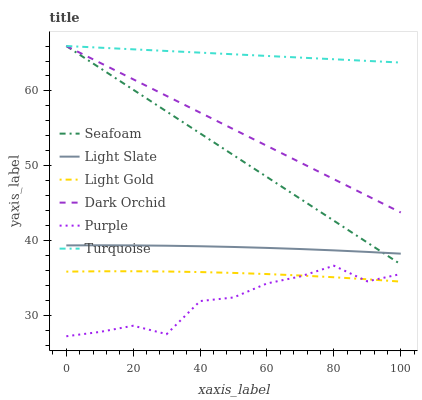Does Purple have the minimum area under the curve?
Answer yes or no. Yes. Does Turquoise have the maximum area under the curve?
Answer yes or no. Yes. Does Light Slate have the minimum area under the curve?
Answer yes or no. No. Does Light Slate have the maximum area under the curve?
Answer yes or no. No. Is Seafoam the smoothest?
Answer yes or no. Yes. Is Purple the roughest?
Answer yes or no. Yes. Is Light Slate the smoothest?
Answer yes or no. No. Is Light Slate the roughest?
Answer yes or no. No. Does Light Slate have the lowest value?
Answer yes or no. No. Does Light Slate have the highest value?
Answer yes or no. No. Is Light Gold less than Light Slate?
Answer yes or no. Yes. Is Dark Orchid greater than Light Slate?
Answer yes or no. Yes. Does Light Gold intersect Light Slate?
Answer yes or no. No. 